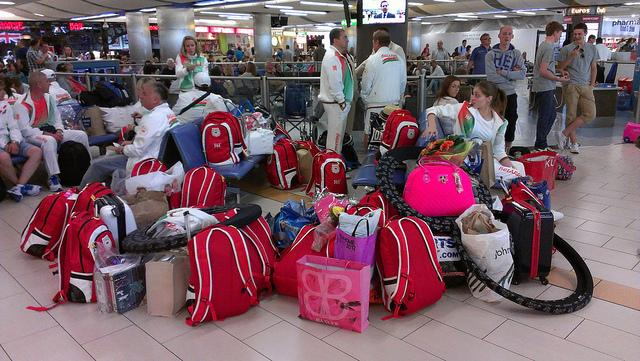Where is this scene taking place? airport 